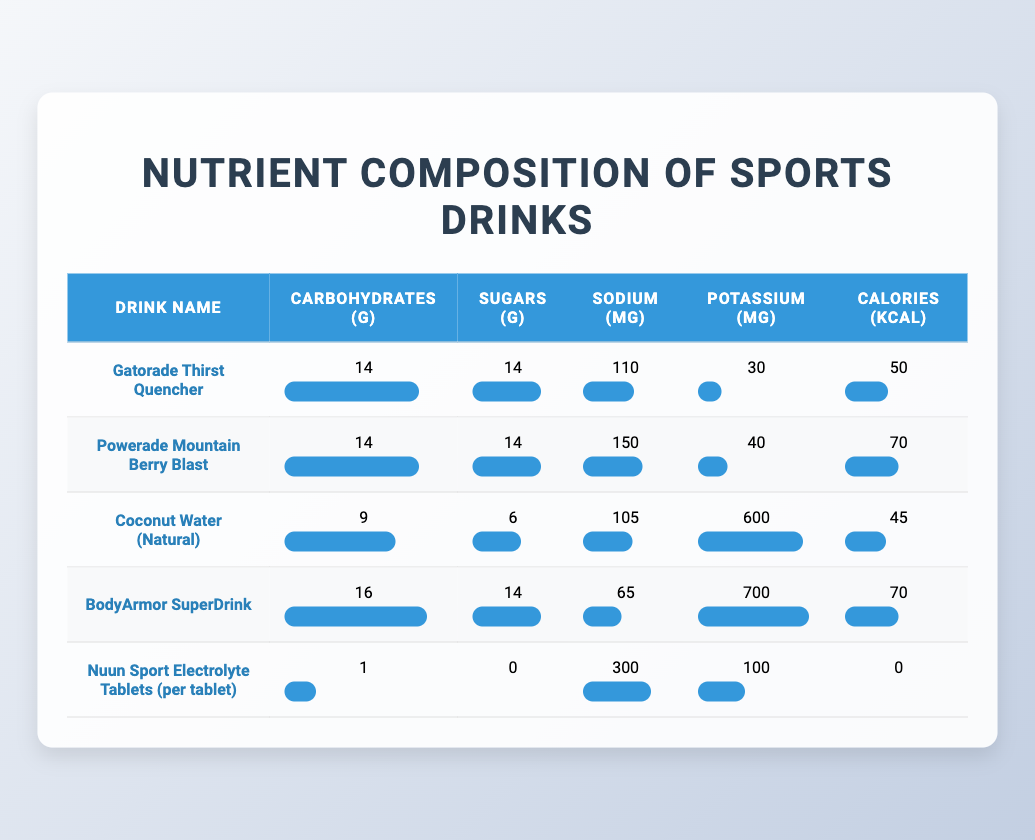What is the total amount of carbohydrates in Powerade Mountain Berry Blast and BodyArmor SuperDrink? To find the total carbohydrates in these two drinks, we add the carbohydrates in Powerade Mountain Berry Blast, which is 14 grams, to those in BodyArmor SuperDrink, which is 16 grams. Therefore, the total carbohydrates are 14 + 16 = 30 grams.
Answer: 30 grams Is the sodium content in Gatorade Thirst Quencher less than that in Coconut Water? The sodium content in Gatorade Thirst Quencher is 110 mg, while in Coconut Water, it is 105 mg. Since 110 mg is greater than 105 mg, the statement is false.
Answer: No Which drink has the highest potassium content? By comparing the potassium values in the table, BodyArmor SuperDrink has 700 mg, which is higher than the others: Powerade Mountain Berry Blast (40 mg), Coconut Water (600 mg), and Gatorade Thirst Quencher (30 mg), as well as Nuun Sport Electrolyte Tablets (100 mg). Thus, BodyArmor SuperDrink has the highest potassium content.
Answer: BodyArmor SuperDrink What is the average sodium content of all five drinks? To calculate the average sodium content, we need to sum the sodium amounts: 110 (Gatorade) + 150 (Powerade) + 105 (Coconut Water) + 65 (BodyArmor) + 300 (Nuun) = 730 mg. There are 5 drinks, so the average sodium content is 730 mg / 5 = 146 mg.
Answer: 146 mg Is the calorie content of Coconut Water greater than the calorie content of Nuun Sport Electrolyte Tablets? The calorie content in Coconut Water is 45 kcal and for Nuun Sport Electrolyte Tablets, it is 0 kcal. Since 45 kcal is greater than 0 kcal, the statement is true.
Answer: Yes What is the difference in sugar content between the drink with the highest sugar and the drink with the lowest sugar? The highest sugar content is found in both Gatorade and Powerade, which contain 14 g each. The Nuun Sport Electrolyte Tablets have the lowest sugar content at 0 g. The difference is calculated as 14 - 0 = 14 g.
Answer: 14 g Which drink has the lowest calories per gram of carbohydrates? First, we will calculate the calories per gram of carbohydrates for each drink: Gatorade: 50/14 ≈ 3.57, Powerade: 70/14 ≈ 5.00, Coconut Water: 45/9 ≈ 5.00, BodyArmor: 70/16 ≈ 4.38, and Nuun: 0/1 = 0. Since the lowest value is for the Nuun Sport Electrolyte Tablets, it has the lowest calories per gram of carbohydrates.
Answer: Nuun Sport Electrolyte Tablets What is the total sugar content of all drinks combined? To find the total sugar content, we add them together: Gatorade (14 g) + Powerade (14 g) + Coconut Water (6 g) + BodyArmor (14 g) + Nuun (0 g) = 48 g total sugar.
Answer: 48 g Which drink has the highest calorie content and how does it compare to BodyArmor SuperDrink? The drink with the highest calorie content in this data is Powerade Mountain Berry Blast at 70 kcal. In comparison, BodyArmor SuperDrink also has 70 kcal, making them equal.
Answer: Equal, both have 70 kcal 